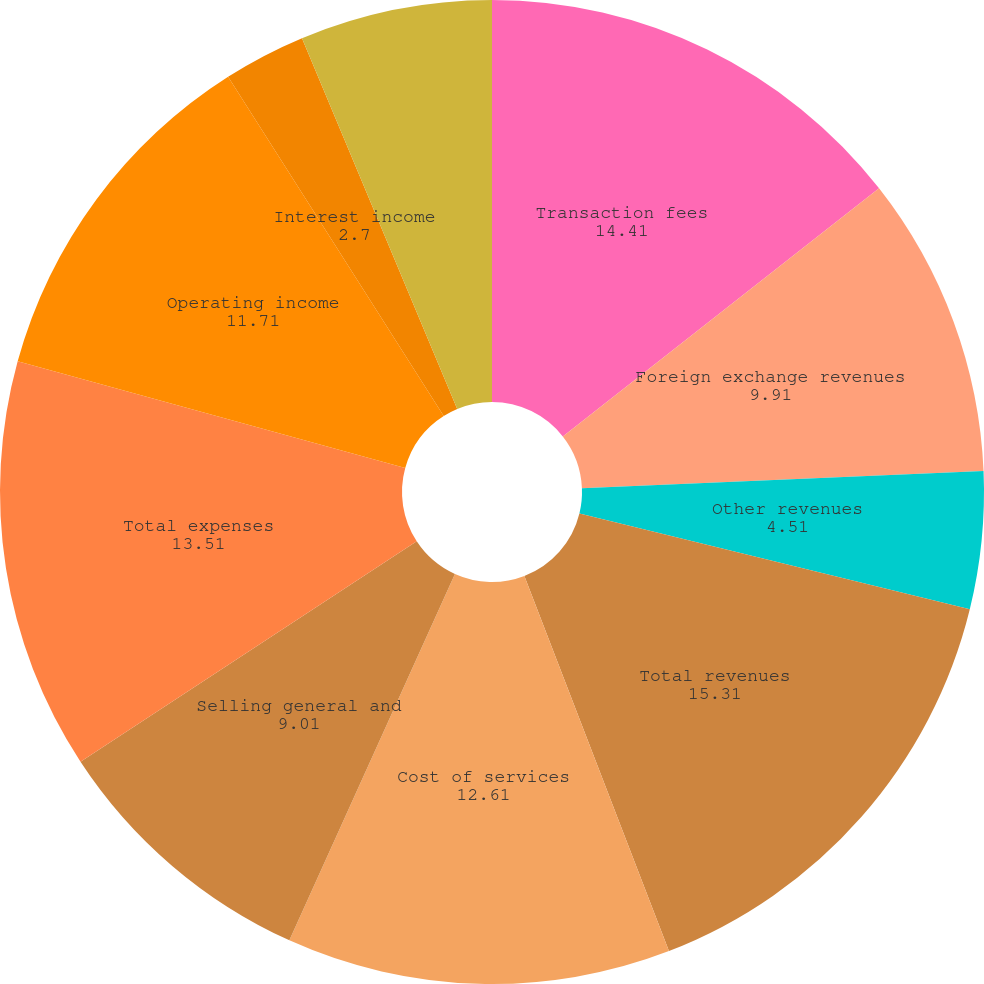Convert chart. <chart><loc_0><loc_0><loc_500><loc_500><pie_chart><fcel>Transaction fees<fcel>Foreign exchange revenues<fcel>Other revenues<fcel>Total revenues<fcel>Cost of services<fcel>Selling general and<fcel>Total expenses<fcel>Operating income<fcel>Interest income<fcel>Interest expense<nl><fcel>14.41%<fcel>9.91%<fcel>4.51%<fcel>15.31%<fcel>12.61%<fcel>9.01%<fcel>13.51%<fcel>11.71%<fcel>2.7%<fcel>6.31%<nl></chart> 